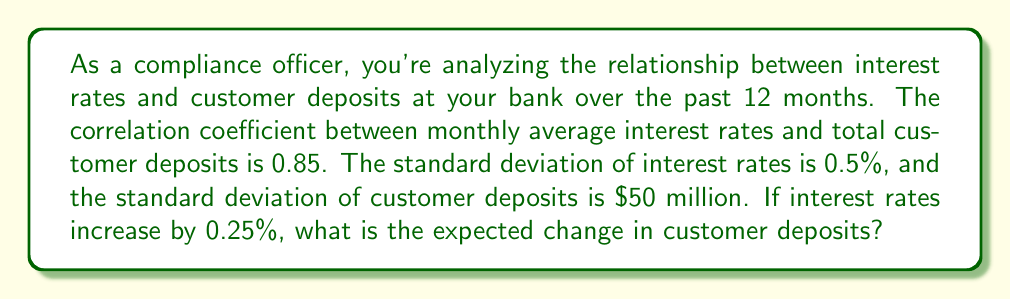Teach me how to tackle this problem. Let's approach this step-by-step:

1) The formula for the correlation coefficient (r) is:
   $$r = \frac{\text{Cov}(X,Y)}{\sigma_X \sigma_Y}$$
   where Cov(X,Y) is the covariance between X and Y, and σ_X and σ_Y are the standard deviations of X and Y respectively.

2) We're given:
   r = 0.85
   σ_X (std dev of interest rates) = 0.5%
   σ_Y (std dev of customer deposits) = $50 million

3) Rearranging the formula to solve for covariance:
   $$\text{Cov}(X,Y) = r \cdot \sigma_X \cdot \sigma_Y$$

4) Plugging in the values:
   $$\text{Cov}(X,Y) = 0.85 \cdot 0.5\% \cdot \$50\text{ million} = \$212,500\text{ million } \%$$

5) The slope of the regression line (b) is given by:
   $$b = \frac{\text{Cov}(X,Y)}{\sigma_X^2}$$

6) Calculating:
   $$b = \frac{\$212,500\text{ million } \%}{(0.5\%)^2} = \$85\text{ billion}$$

7) This means that for every 1% increase in interest rates, we expect an $85 billion increase in deposits.

8) For a 0.25% increase, we multiply this by 0.25:
   $$0.25 \cdot \$85\text{ billion} = \$21.25\text{ billion}$$

Therefore, for a 0.25% increase in interest rates, we expect an increase of $21.25 billion in customer deposits.
Answer: $21.25 billion 